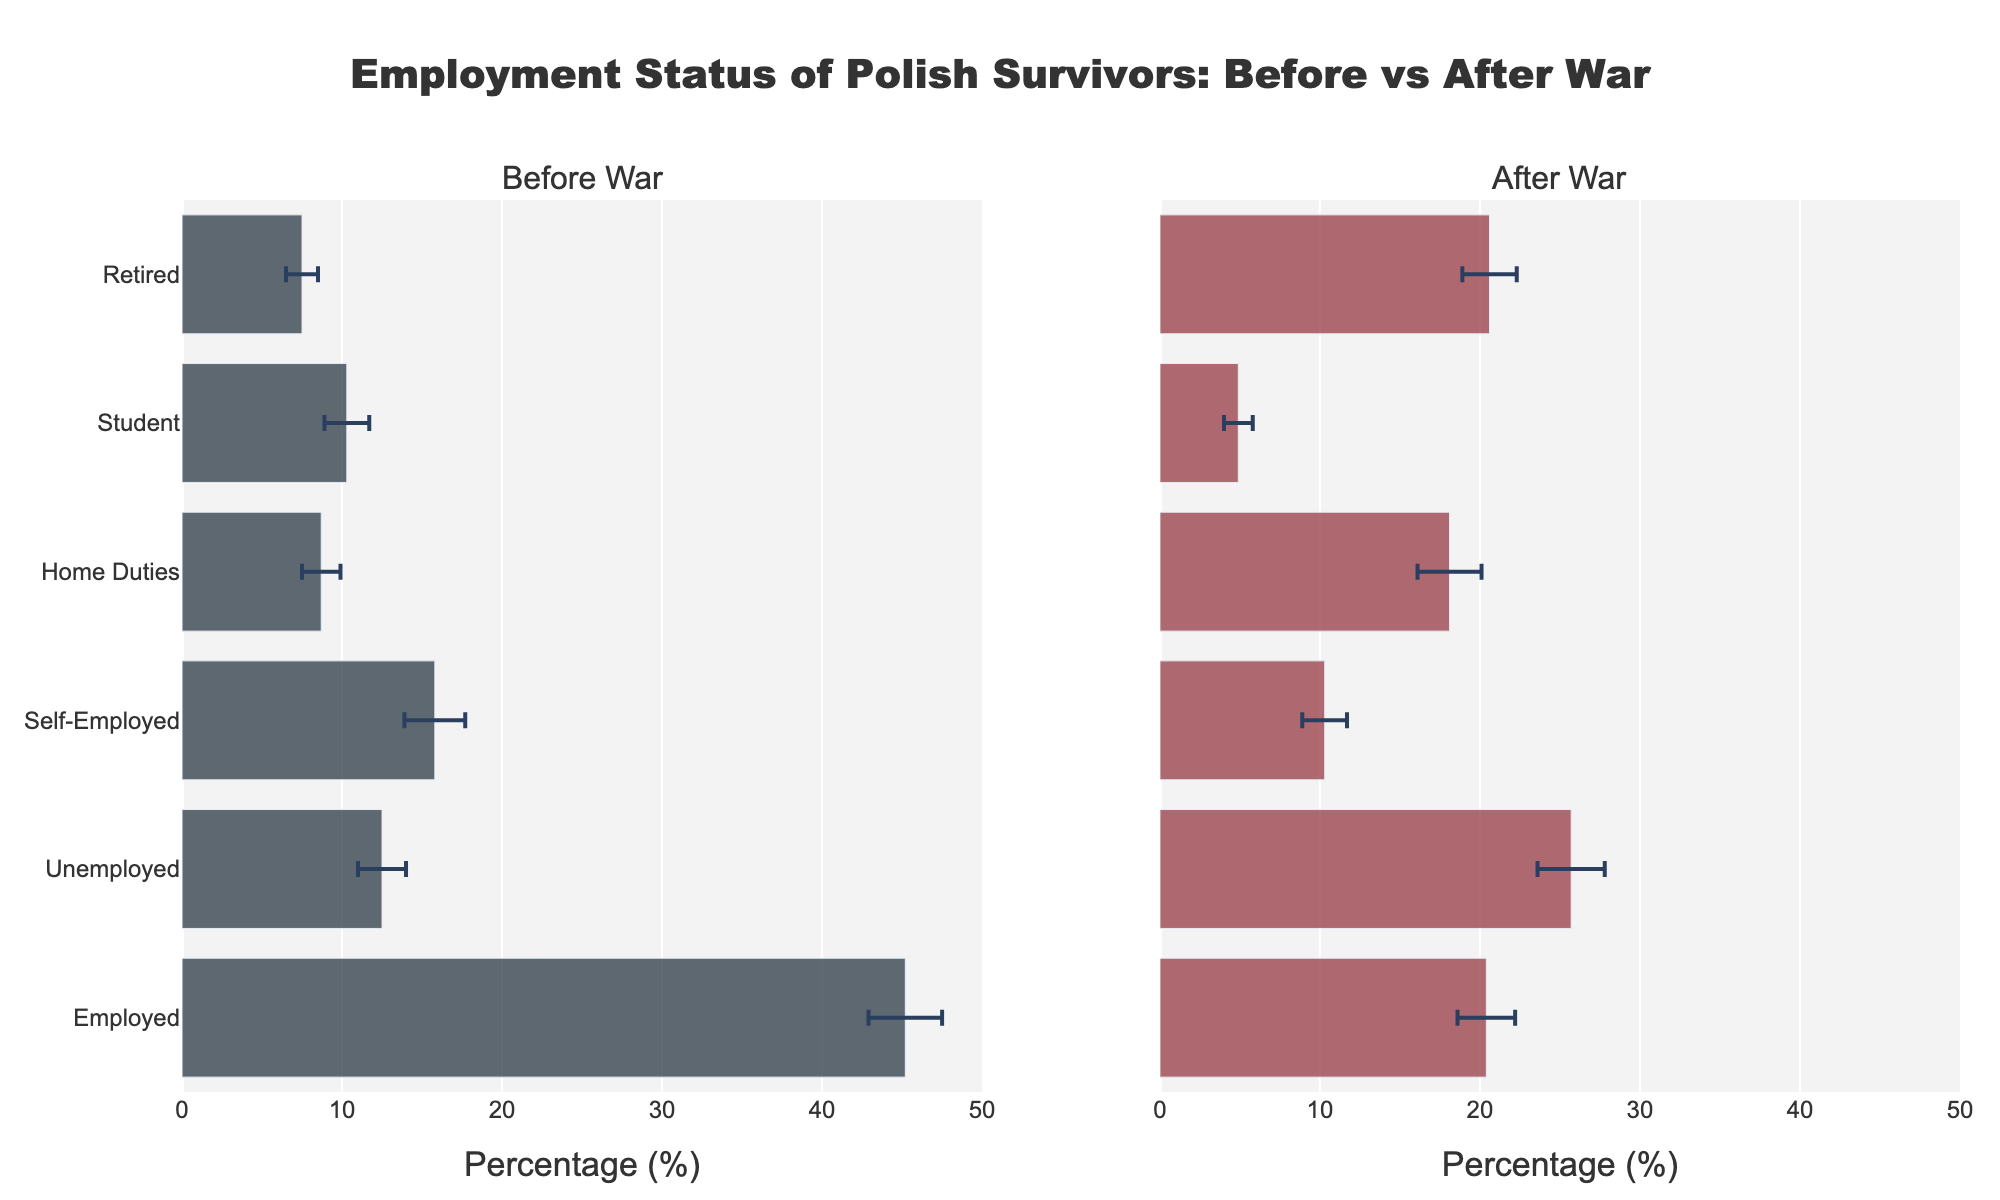What is the title of the figure? The title of the figure is generally displayed at the top of the chart. In this case, it reads "Employment Status of Polish Survivors: Before vs After War."
Answer: Employment Status of Polish Survivors: Before vs After War Which employment status category has the highest average percentage before the war? Look at the bar lengths in the "Before War" section. The "Employed" category has the longest bar, indicating the highest average percentage.
Answer: Employed What is the average percentage of unemployed individuals after the war? In the "After War" section, locate the bar for "Unemployed" and read its length. The average percentage is 25.7%.
Answer: 25.7% How much did the average percentage of employed individuals decrease from before to after the war? Subtract the average percentage after the war (20.4%) from the average percentage before the war (45.2%) for the "Employed" category. 45.2% - 20.4% = 24.8%.
Answer: 24.8% What is the range of data used on the x-axes to show the percentages? The x-axes for both subplots are labeled "Percentage (%)" and range from 0 to 50, with ticks every 10 units.
Answer: 0 to 50 Which employment status category has the largest increase in average percentage after the war? Compare the differences between before and after war percentages for each category. The "Unemployed" category increased from 12.5% to 25.7%, a difference of 13.2%.
Answer: Unemployed Which employment status has the smallest error bar in the after-war section? In the "After War" section, identify the category with the shortest error bar. The "Student" category has the smallest error margin, 0.9%.
Answer: Student Are there any categories where the error bars overlap when comparing before and after the war? Visually check for overlaps in the error bars between the "Before War" and "After War" percentages across all categories. The "Retired" and "Home Duties" categories show some overlapping error bars.
Answer: Yes (Retired, Home Duties) Which two categories have shown an increase in percentage of respondents involved in home duties or unemployed after the war? The "Unemployed" and "Home Duties" categories have both shown an increase in their average percentages after the war compared to before the war.
Answer: Unemployed, Home Duties 